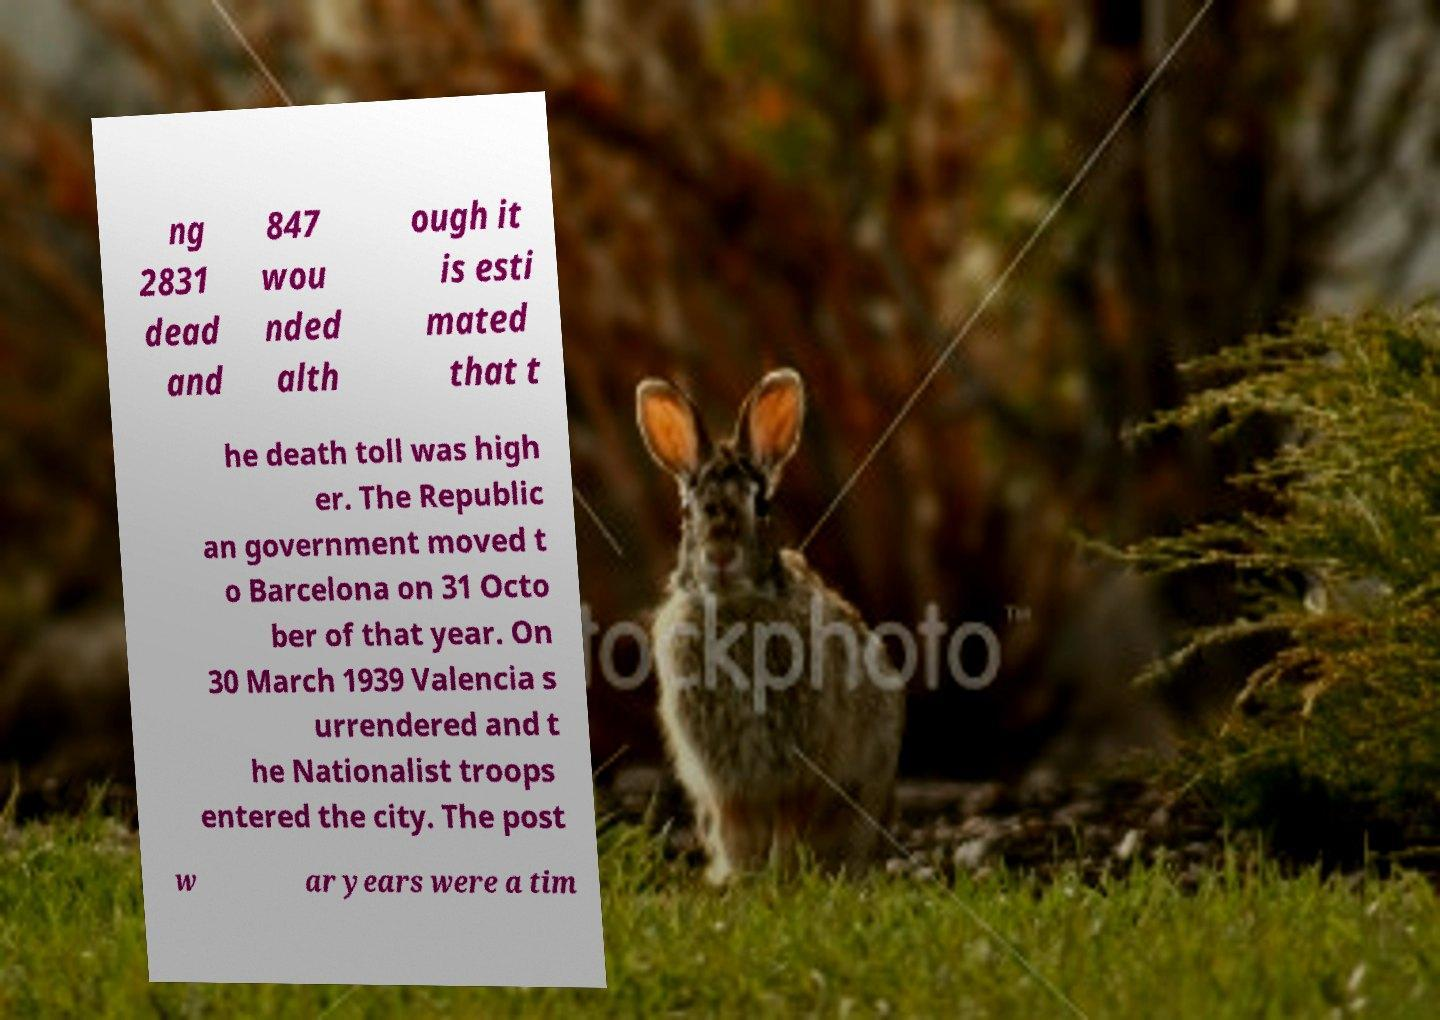What messages or text are displayed in this image? I need them in a readable, typed format. ng 2831 dead and 847 wou nded alth ough it is esti mated that t he death toll was high er. The Republic an government moved t o Barcelona on 31 Octo ber of that year. On 30 March 1939 Valencia s urrendered and t he Nationalist troops entered the city. The post w ar years were a tim 